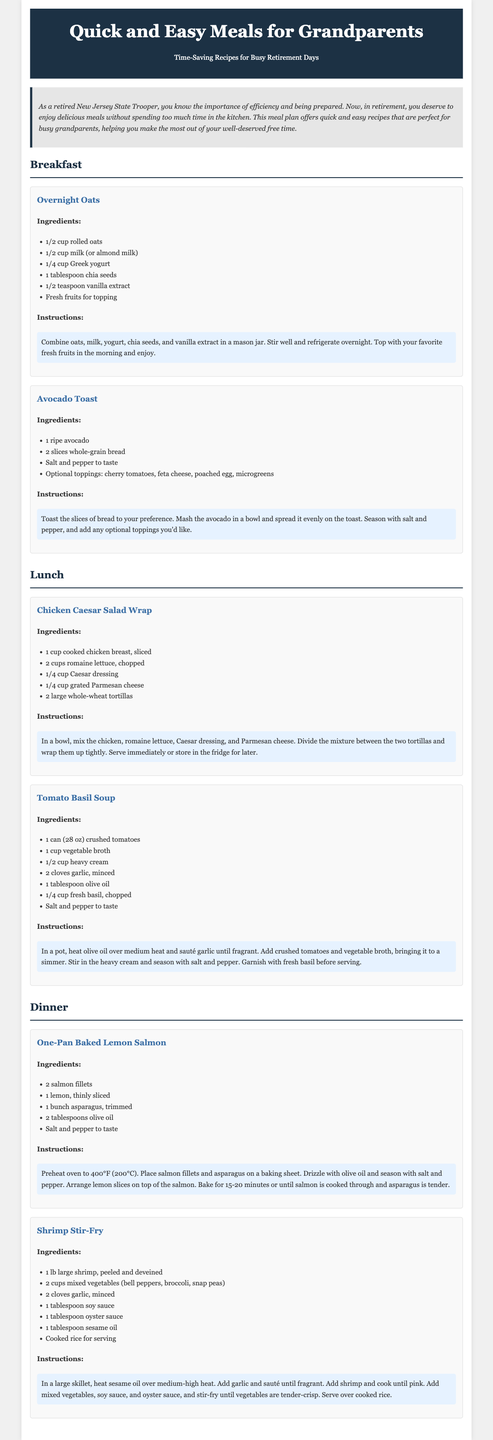What are the breakfast recipes listed? The document lists two breakfast recipes: "Overnight Oats" and "Avocado Toast."
Answer: Overnight Oats, Avocado Toast How many ingredients are needed for the Chicken Caesar Salad Wrap? The Chicken Caesar Salad Wrap recipe lists five ingredients.
Answer: 5 What is the cooking time for the One-Pan Baked Lemon Salmon? The cooking time indicated in the recipe is 15-20 minutes.
Answer: 15-20 minutes What is the main ingredient in the Tomato Basil Soup? The main ingredient in the Tomato Basil Soup is crushed tomatoes.
Answer: Crushed tomatoes Which meal section includes the Shrimp Stir-Fry? The Shrimp Stir-Fry is included in the Dinner section of the meal plan.
Answer: Dinner 